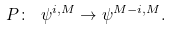Convert formula to latex. <formula><loc_0><loc_0><loc_500><loc_500>P \colon \ \psi ^ { i , M } \rightarrow \psi ^ { M - i , M } .</formula> 